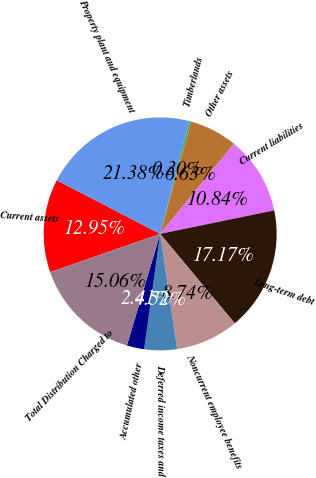Convert chart to OTSL. <chart><loc_0><loc_0><loc_500><loc_500><pie_chart><fcel>Current assets<fcel>Property plant and equipment<fcel>Timberlands<fcel>Other assets<fcel>Current liabilities<fcel>Long-term debt<fcel>Noncurrent employee benefits<fcel>Deferred income taxes and<fcel>Accumulated other<fcel>Total Distribution Charged to<nl><fcel>12.95%<fcel>21.38%<fcel>0.3%<fcel>6.63%<fcel>10.84%<fcel>17.17%<fcel>8.74%<fcel>4.52%<fcel>2.41%<fcel>15.06%<nl></chart> 